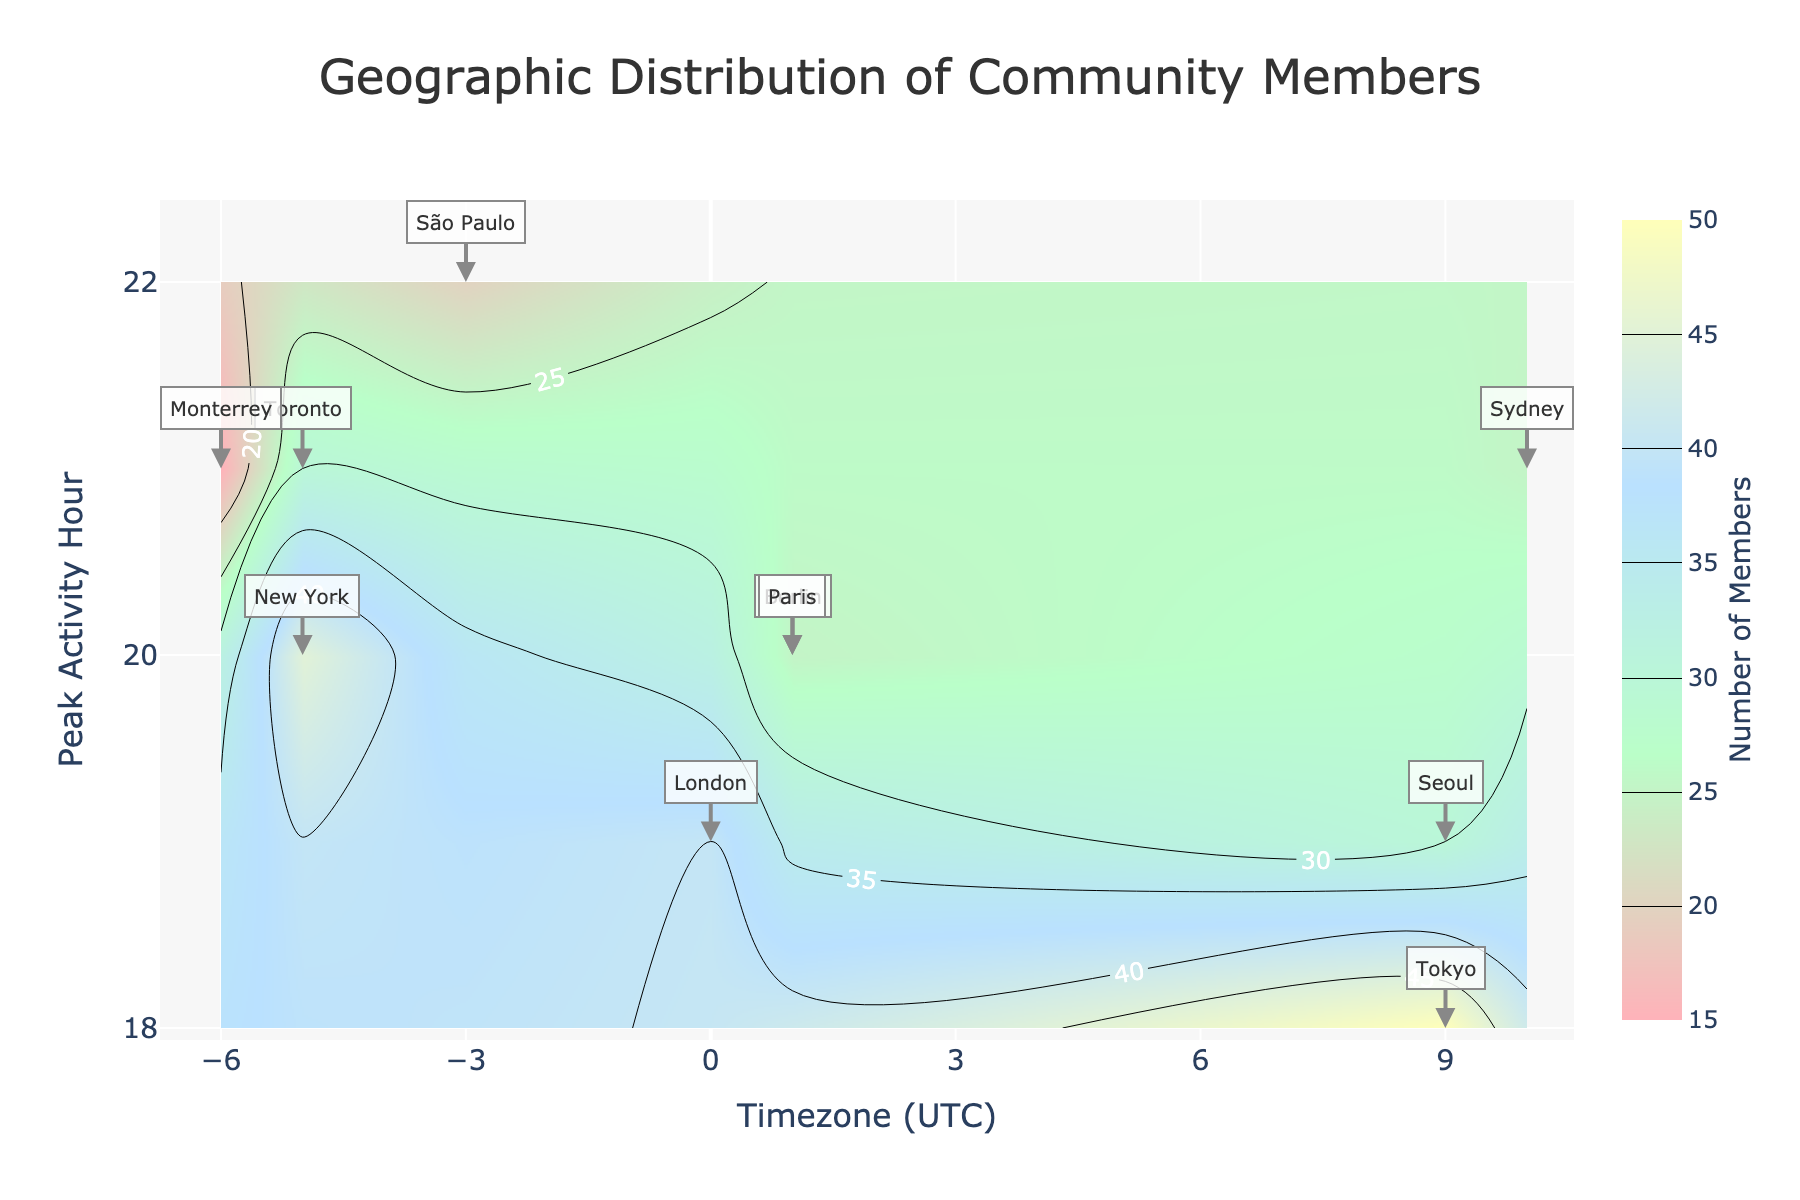What is the title of the plot? The title of the plot is located at the top center of the figure. It reads "Geographic Distribution of Community Members."
Answer: Geographic Distribution of Community Members Which timezone has the highest number of members? By looking at the contour levels and the colorbar, the timezone with the highest color intensity indicates the highest number of members. This region appears at UTC+9.
Answer: UTC+9 What are the axes representing in the plot? The x-axis represents the timezones in UTC, and the y-axis represents the peak activity hour of the day. This information is provided by the axis titles.
Answer: Timezones and peak activity hour Which city has the lowest number of members? Investigate the figure to find the contour region with the least color intensity and then look for the city label closest to that region. It appears to be Monterrey in UTC-6.
Answer: Monterrey What is the peak activity hour for most community members in Berlin? Find the "Berlin" label on the plot and note where it intersects on the y-axis. The label is at y=20, which means 20:00 (8 PM) is the peak activity hour for Berlin.
Answer: 20 How many members are there in Sydney? Find the "Sydney" label on the plot and refer to the z-value in that region. According to the hover template, Sydney has 25 members.
Answer: 25 What is the average peak activity hour for cities in UTC+1? Identify the cities in the UTC+1 timezone (Berlin and Paris) and the peak activity hours for these cities. Average these values: (20+20)/2 = 20.
Answer: 20 Which city has a peak activity hour at 19:00? Scan the y-axis at 19 and look for city labels at that height. The city found is London.
Answer: London Is there any city with a peak activity hour at or after 21:00 in the UTC-5 timezone? Check the UTC-5 timezone on the x-axis and look vertically for peak activity hours 21:00 or later. Toronto (21) meets this criterion.
Answer: Yes, Toronto Which cities lie within the UTC+9 timezone? Identify the cities based on their timezone. The cities in the UTC+9 timezone in the figure are Tokyo and Seoul.
Answer: Tokyo and Seoul 